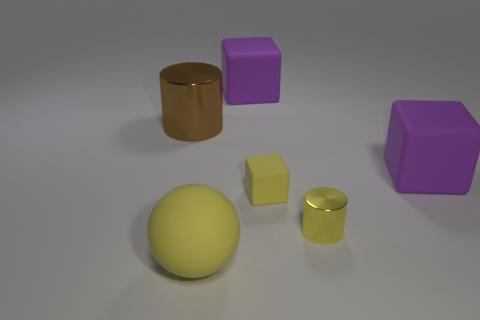There is a big object that is the same color as the tiny rubber block; what is it made of?
Ensure brevity in your answer.  Rubber. Is there another brown shiny thing of the same size as the brown thing?
Make the answer very short. No. Is the number of big brown metallic cylinders left of the big brown metal cylinder greater than the number of small yellow rubber objects to the right of the yellow cylinder?
Give a very brief answer. No. Is the big object behind the big cylinder made of the same material as the object left of the big yellow rubber ball?
Provide a succinct answer. No. There is a yellow shiny thing that is the same size as the yellow matte block; what is its shape?
Ensure brevity in your answer.  Cylinder. Are there any other yellow things that have the same shape as the tiny yellow rubber object?
Keep it short and to the point. No. There is a cylinder behind the yellow shiny cylinder; is it the same color as the large rubber block that is in front of the brown cylinder?
Keep it short and to the point. No. There is a yellow rubber block; are there any small yellow rubber things on the left side of it?
Provide a short and direct response. No. There is a thing that is both behind the tiny yellow cylinder and right of the tiny yellow cube; what is it made of?
Provide a short and direct response. Rubber. Do the small yellow cylinder that is behind the big yellow matte sphere and the large brown object have the same material?
Your answer should be compact. Yes. 